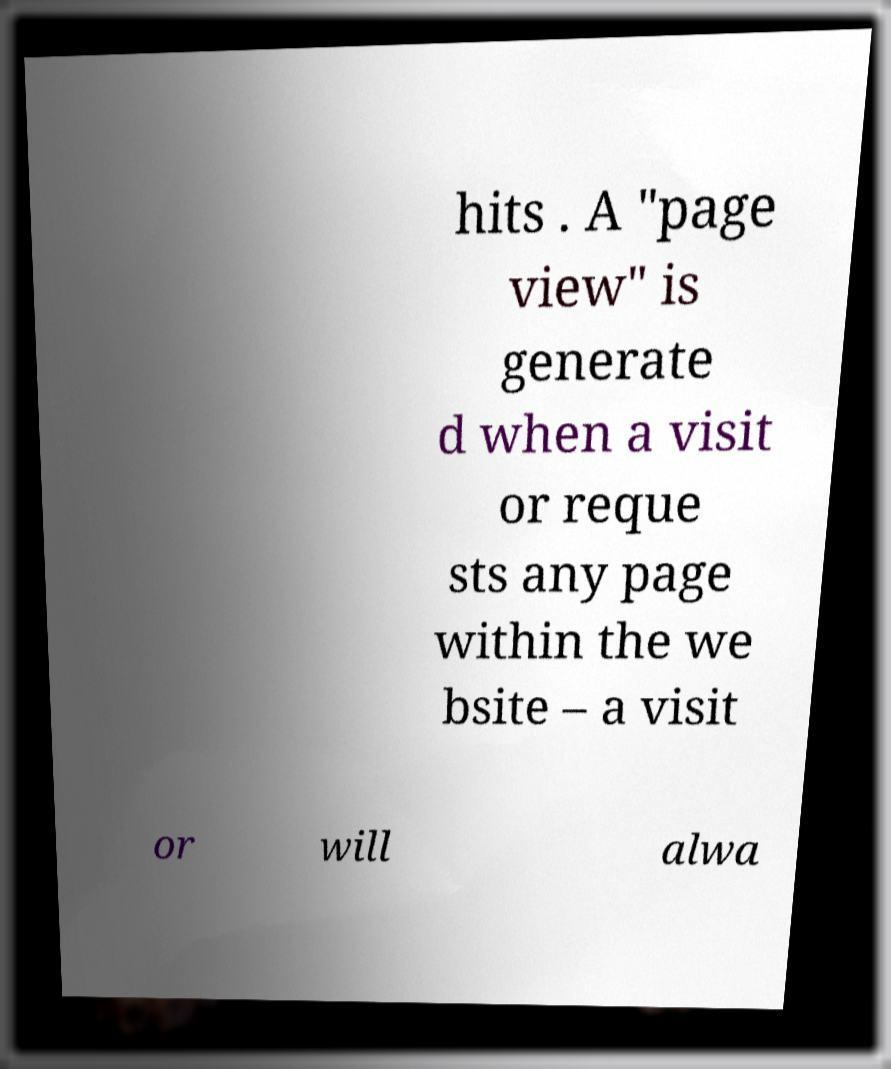Could you extract and type out the text from this image? hits . A "page view" is generate d when a visit or reque sts any page within the we bsite – a visit or will alwa 